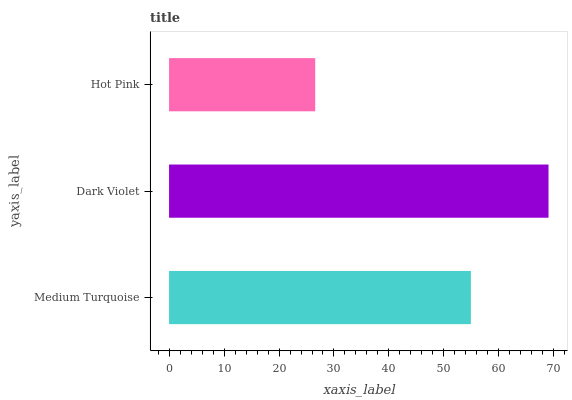Is Hot Pink the minimum?
Answer yes or no. Yes. Is Dark Violet the maximum?
Answer yes or no. Yes. Is Dark Violet the minimum?
Answer yes or no. No. Is Hot Pink the maximum?
Answer yes or no. No. Is Dark Violet greater than Hot Pink?
Answer yes or no. Yes. Is Hot Pink less than Dark Violet?
Answer yes or no. Yes. Is Hot Pink greater than Dark Violet?
Answer yes or no. No. Is Dark Violet less than Hot Pink?
Answer yes or no. No. Is Medium Turquoise the high median?
Answer yes or no. Yes. Is Medium Turquoise the low median?
Answer yes or no. Yes. Is Dark Violet the high median?
Answer yes or no. No. Is Dark Violet the low median?
Answer yes or no. No. 